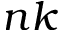Convert formula to latex. <formula><loc_0><loc_0><loc_500><loc_500>n k</formula> 